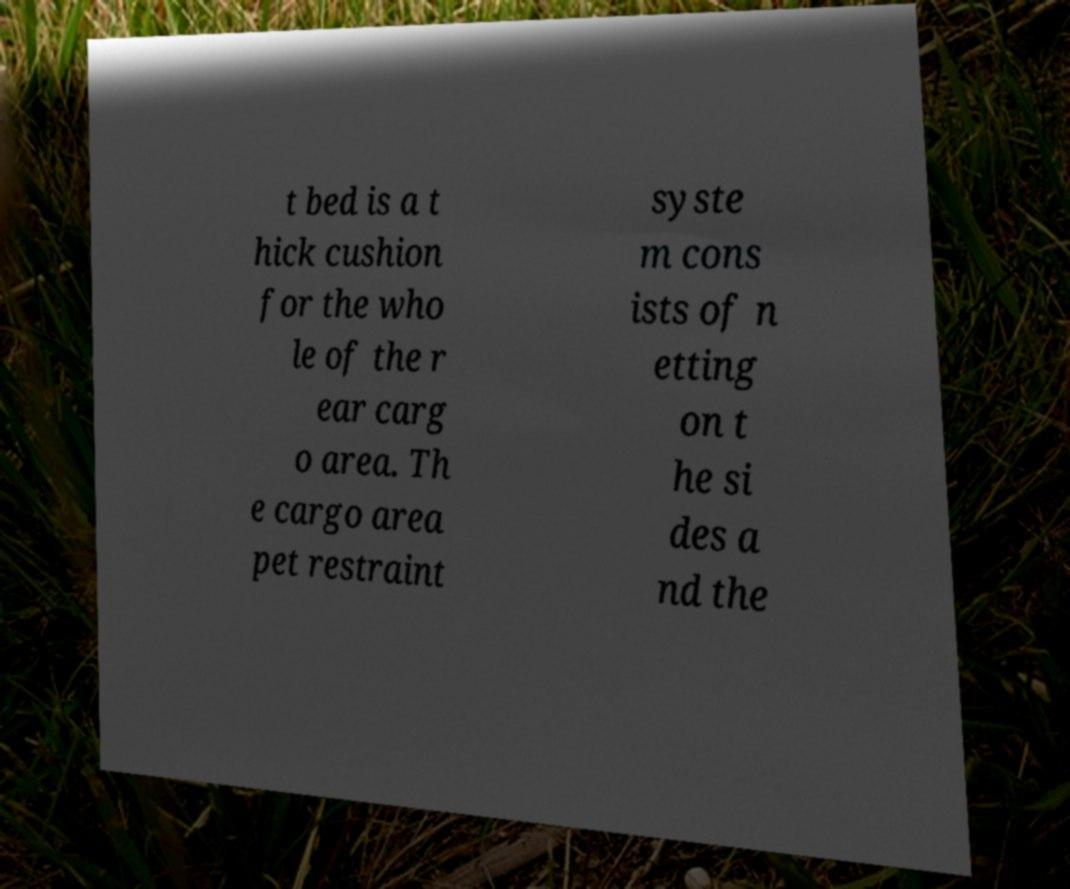Please read and relay the text visible in this image. What does it say? t bed is a t hick cushion for the who le of the r ear carg o area. Th e cargo area pet restraint syste m cons ists of n etting on t he si des a nd the 